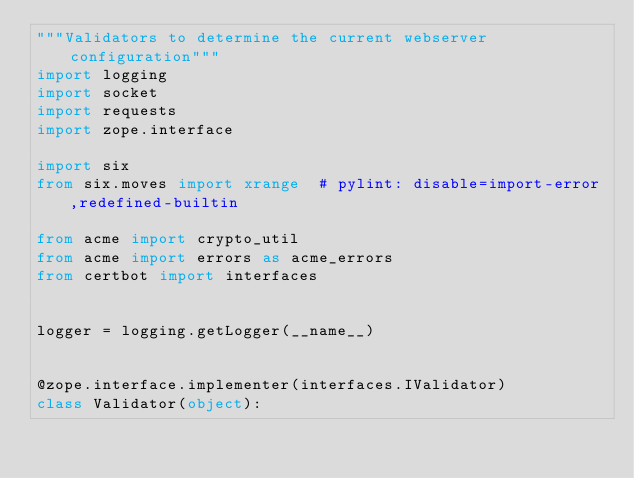<code> <loc_0><loc_0><loc_500><loc_500><_Python_>"""Validators to determine the current webserver configuration"""
import logging
import socket
import requests
import zope.interface

import six
from six.moves import xrange  # pylint: disable=import-error,redefined-builtin

from acme import crypto_util
from acme import errors as acme_errors
from certbot import interfaces


logger = logging.getLogger(__name__)


@zope.interface.implementer(interfaces.IValidator)
class Validator(object):</code> 